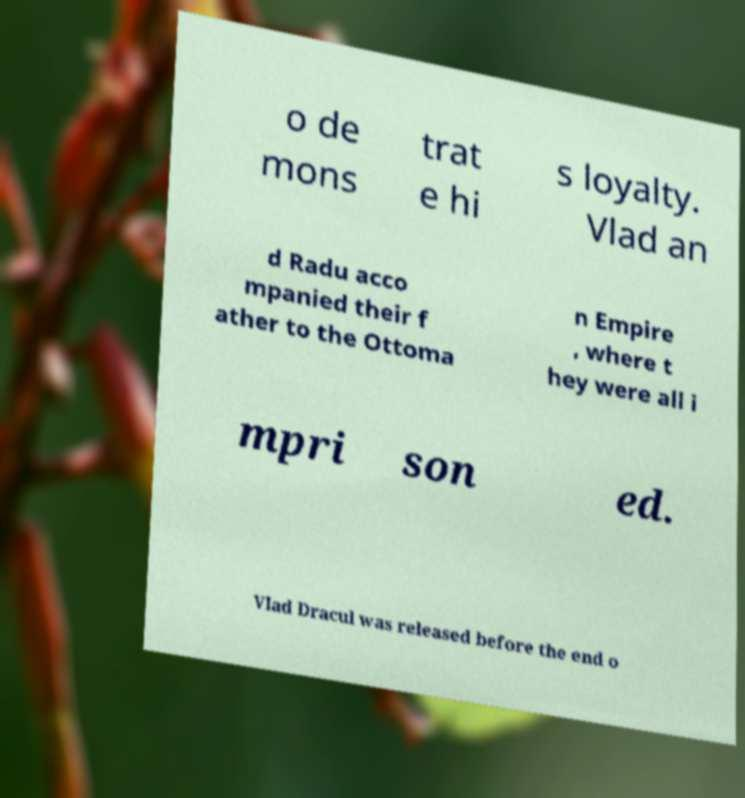Could you extract and type out the text from this image? o de mons trat e hi s loyalty. Vlad an d Radu acco mpanied their f ather to the Ottoma n Empire , where t hey were all i mpri son ed. Vlad Dracul was released before the end o 